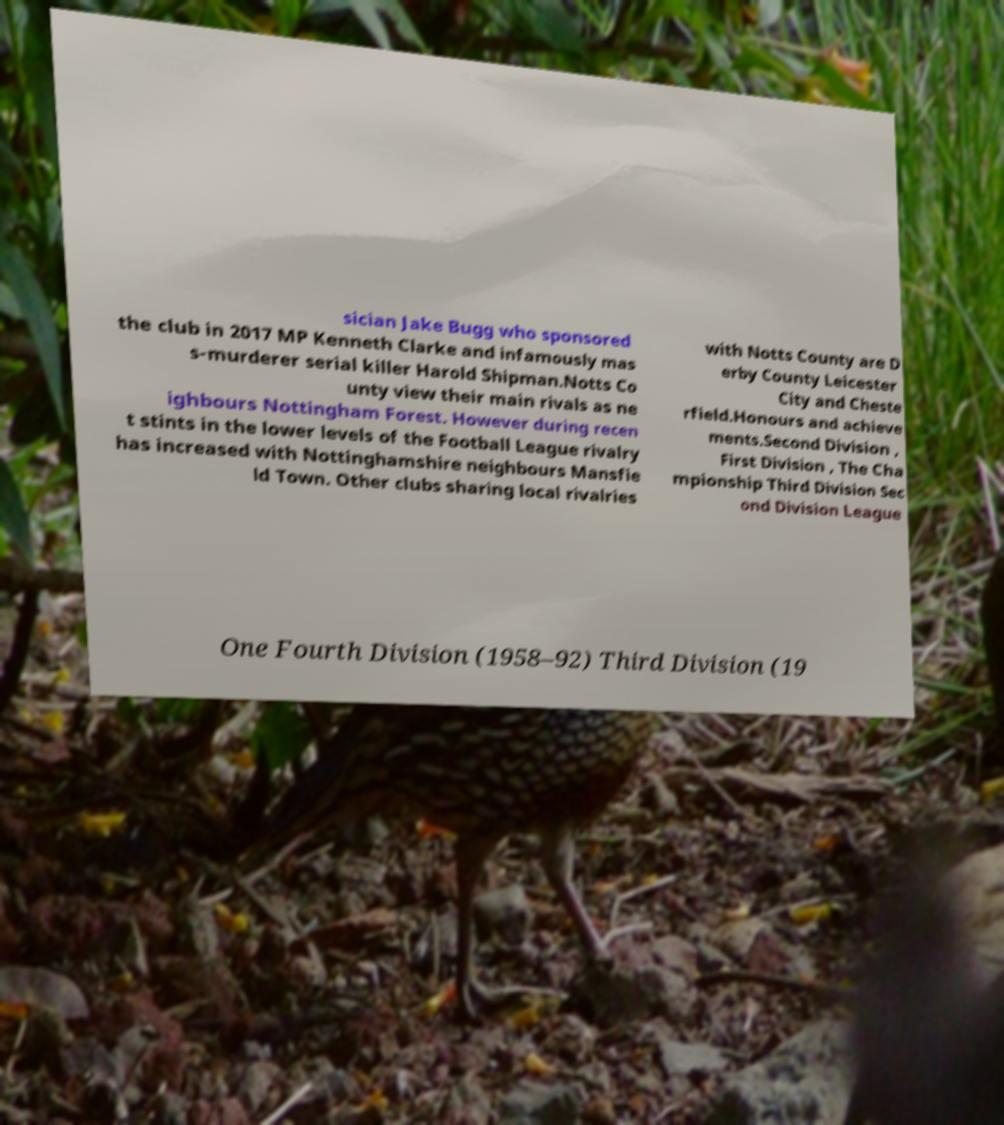Please read and relay the text visible in this image. What does it say? sician Jake Bugg who sponsored the club in 2017 MP Kenneth Clarke and infamously mas s-murderer serial killer Harold Shipman.Notts Co unty view their main rivals as ne ighbours Nottingham Forest. However during recen t stints in the lower levels of the Football League rivalry has increased with Nottinghamshire neighbours Mansfie ld Town. Other clubs sharing local rivalries with Notts County are D erby County Leicester City and Cheste rfield.Honours and achieve ments.Second Division , First Division , The Cha mpionship Third Division Sec ond Division League One Fourth Division (1958–92) Third Division (19 